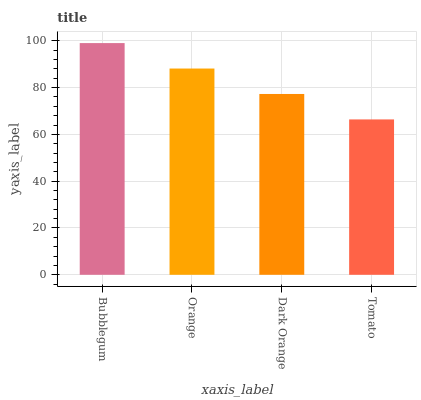Is Orange the minimum?
Answer yes or no. No. Is Orange the maximum?
Answer yes or no. No. Is Bubblegum greater than Orange?
Answer yes or no. Yes. Is Orange less than Bubblegum?
Answer yes or no. Yes. Is Orange greater than Bubblegum?
Answer yes or no. No. Is Bubblegum less than Orange?
Answer yes or no. No. Is Orange the high median?
Answer yes or no. Yes. Is Dark Orange the low median?
Answer yes or no. Yes. Is Dark Orange the high median?
Answer yes or no. No. Is Orange the low median?
Answer yes or no. No. 